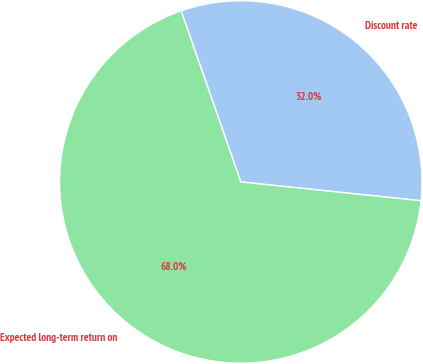<chart> <loc_0><loc_0><loc_500><loc_500><pie_chart><fcel>Discount rate<fcel>Expected long-term return on<nl><fcel>32.0%<fcel>68.0%<nl></chart> 